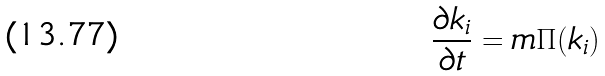Convert formula to latex. <formula><loc_0><loc_0><loc_500><loc_500>\frac { \partial k _ { i } } { \partial t } = m \Pi ( k _ { i } )</formula> 